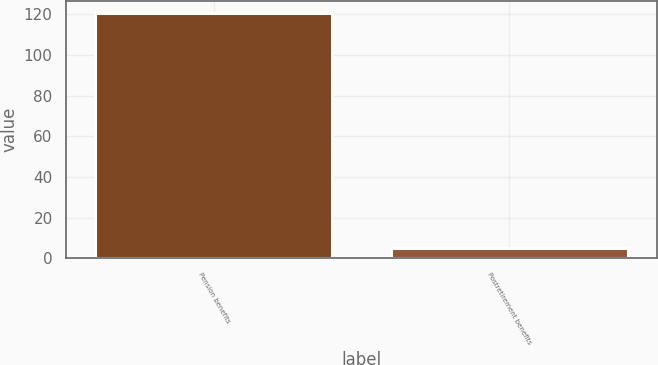Convert chart to OTSL. <chart><loc_0><loc_0><loc_500><loc_500><bar_chart><fcel>Pension benefits<fcel>Postretirement benefits<nl><fcel>120.6<fcel>5<nl></chart> 